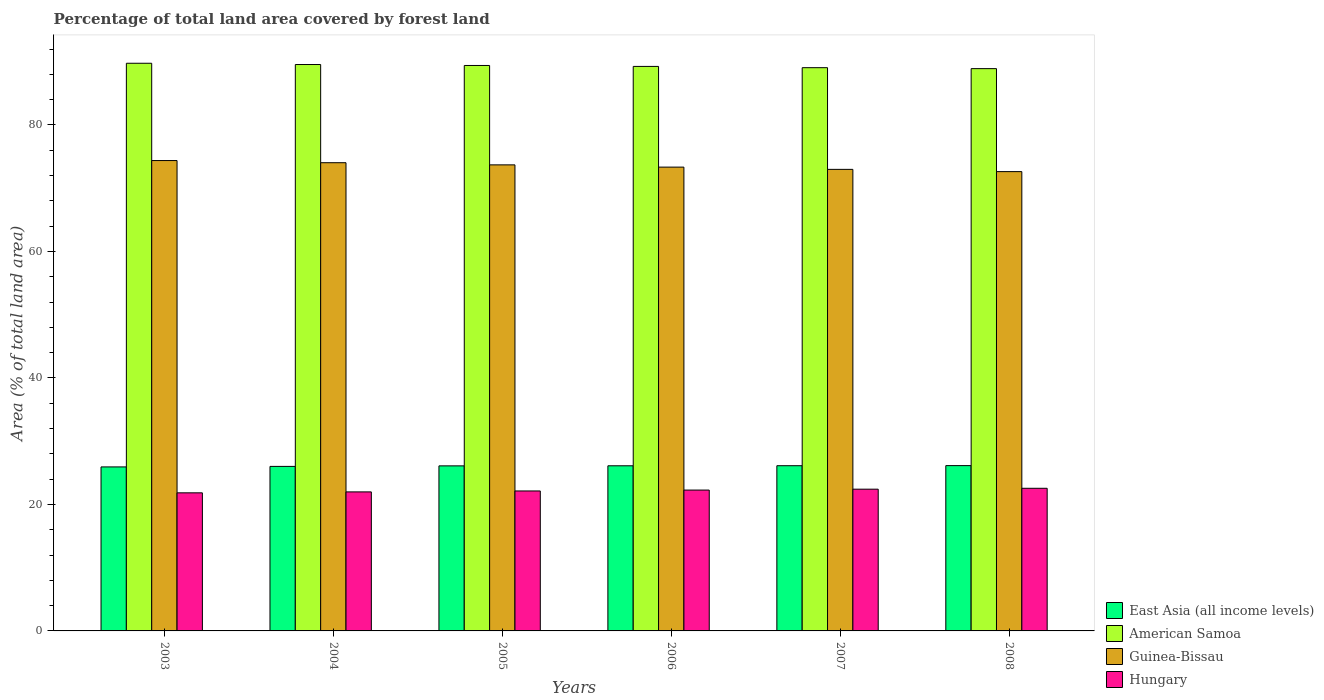Are the number of bars per tick equal to the number of legend labels?
Provide a succinct answer. Yes. How many bars are there on the 4th tick from the left?
Provide a succinct answer. 4. How many bars are there on the 3rd tick from the right?
Make the answer very short. 4. What is the label of the 2nd group of bars from the left?
Your response must be concise. 2004. What is the percentage of forest land in Guinea-Bissau in 2006?
Offer a very short reply. 73.33. Across all years, what is the maximum percentage of forest land in East Asia (all income levels)?
Keep it short and to the point. 26.14. Across all years, what is the minimum percentage of forest land in American Samoa?
Keep it short and to the point. 88.9. In which year was the percentage of forest land in East Asia (all income levels) minimum?
Give a very brief answer. 2003. What is the total percentage of forest land in Hungary in the graph?
Give a very brief answer. 133.17. What is the difference between the percentage of forest land in East Asia (all income levels) in 2005 and that in 2007?
Offer a very short reply. -0.03. What is the difference between the percentage of forest land in American Samoa in 2008 and the percentage of forest land in Hungary in 2003?
Give a very brief answer. 67.07. What is the average percentage of forest land in American Samoa per year?
Make the answer very short. 89.32. In the year 2007, what is the difference between the percentage of forest land in American Samoa and percentage of forest land in Guinea-Bissau?
Provide a short and direct response. 16.08. What is the ratio of the percentage of forest land in Guinea-Bissau in 2003 to that in 2008?
Offer a very short reply. 1.02. Is the percentage of forest land in American Samoa in 2004 less than that in 2008?
Offer a very short reply. No. What is the difference between the highest and the second highest percentage of forest land in Guinea-Bissau?
Your answer should be compact. 0.34. What is the difference between the highest and the lowest percentage of forest land in Guinea-Bissau?
Keep it short and to the point. 1.75. Is it the case that in every year, the sum of the percentage of forest land in Guinea-Bissau and percentage of forest land in Hungary is greater than the sum of percentage of forest land in East Asia (all income levels) and percentage of forest land in American Samoa?
Give a very brief answer. No. What does the 4th bar from the left in 2003 represents?
Offer a very short reply. Hungary. What does the 1st bar from the right in 2004 represents?
Provide a succinct answer. Hungary. Is it the case that in every year, the sum of the percentage of forest land in Hungary and percentage of forest land in East Asia (all income levels) is greater than the percentage of forest land in Guinea-Bissau?
Your answer should be very brief. No. How many bars are there?
Your response must be concise. 24. Are all the bars in the graph horizontal?
Your answer should be compact. No. What is the difference between two consecutive major ticks on the Y-axis?
Provide a short and direct response. 20. How many legend labels are there?
Keep it short and to the point. 4. What is the title of the graph?
Give a very brief answer. Percentage of total land area covered by forest land. Does "Nicaragua" appear as one of the legend labels in the graph?
Provide a short and direct response. No. What is the label or title of the Y-axis?
Give a very brief answer. Area (% of total land area). What is the Area (% of total land area) of East Asia (all income levels) in 2003?
Provide a short and direct response. 25.93. What is the Area (% of total land area) of American Samoa in 2003?
Your answer should be compact. 89.75. What is the Area (% of total land area) of Guinea-Bissau in 2003?
Provide a short and direct response. 74.37. What is the Area (% of total land area) in Hungary in 2003?
Make the answer very short. 21.83. What is the Area (% of total land area) of East Asia (all income levels) in 2004?
Your answer should be very brief. 26.01. What is the Area (% of total land area) of American Samoa in 2004?
Keep it short and to the point. 89.55. What is the Area (% of total land area) of Guinea-Bissau in 2004?
Give a very brief answer. 74.03. What is the Area (% of total land area) in Hungary in 2004?
Offer a very short reply. 21.98. What is the Area (% of total land area) of East Asia (all income levels) in 2005?
Make the answer very short. 26.09. What is the Area (% of total land area) of American Samoa in 2005?
Your answer should be very brief. 89.4. What is the Area (% of total land area) of Guinea-Bissau in 2005?
Keep it short and to the point. 73.68. What is the Area (% of total land area) in Hungary in 2005?
Keep it short and to the point. 22.13. What is the Area (% of total land area) of East Asia (all income levels) in 2006?
Keep it short and to the point. 26.11. What is the Area (% of total land area) in American Samoa in 2006?
Make the answer very short. 89.25. What is the Area (% of total land area) of Guinea-Bissau in 2006?
Your response must be concise. 73.33. What is the Area (% of total land area) in Hungary in 2006?
Offer a very short reply. 22.27. What is the Area (% of total land area) in East Asia (all income levels) in 2007?
Your response must be concise. 26.12. What is the Area (% of total land area) of American Samoa in 2007?
Offer a terse response. 89.05. What is the Area (% of total land area) in Guinea-Bissau in 2007?
Your response must be concise. 72.97. What is the Area (% of total land area) of Hungary in 2007?
Keep it short and to the point. 22.41. What is the Area (% of total land area) of East Asia (all income levels) in 2008?
Ensure brevity in your answer.  26.14. What is the Area (% of total land area) in American Samoa in 2008?
Offer a terse response. 88.9. What is the Area (% of total land area) of Guinea-Bissau in 2008?
Your response must be concise. 72.62. What is the Area (% of total land area) of Hungary in 2008?
Your answer should be very brief. 22.55. Across all years, what is the maximum Area (% of total land area) of East Asia (all income levels)?
Your answer should be very brief. 26.14. Across all years, what is the maximum Area (% of total land area) in American Samoa?
Provide a succinct answer. 89.75. Across all years, what is the maximum Area (% of total land area) in Guinea-Bissau?
Offer a terse response. 74.37. Across all years, what is the maximum Area (% of total land area) of Hungary?
Make the answer very short. 22.55. Across all years, what is the minimum Area (% of total land area) of East Asia (all income levels)?
Your answer should be very brief. 25.93. Across all years, what is the minimum Area (% of total land area) of American Samoa?
Give a very brief answer. 88.9. Across all years, what is the minimum Area (% of total land area) of Guinea-Bissau?
Provide a short and direct response. 72.62. Across all years, what is the minimum Area (% of total land area) of Hungary?
Provide a short and direct response. 21.83. What is the total Area (% of total land area) of East Asia (all income levels) in the graph?
Ensure brevity in your answer.  156.4. What is the total Area (% of total land area) in American Samoa in the graph?
Make the answer very short. 535.9. What is the total Area (% of total land area) of Guinea-Bissau in the graph?
Provide a short and direct response. 441. What is the total Area (% of total land area) in Hungary in the graph?
Give a very brief answer. 133.17. What is the difference between the Area (% of total land area) in East Asia (all income levels) in 2003 and that in 2004?
Offer a terse response. -0.08. What is the difference between the Area (% of total land area) in American Samoa in 2003 and that in 2004?
Your answer should be compact. 0.2. What is the difference between the Area (% of total land area) of Guinea-Bissau in 2003 and that in 2004?
Make the answer very short. 0.34. What is the difference between the Area (% of total land area) of Hungary in 2003 and that in 2004?
Offer a terse response. -0.15. What is the difference between the Area (% of total land area) in East Asia (all income levels) in 2003 and that in 2005?
Offer a very short reply. -0.16. What is the difference between the Area (% of total land area) of American Samoa in 2003 and that in 2005?
Your answer should be very brief. 0.35. What is the difference between the Area (% of total land area) of Guinea-Bissau in 2003 and that in 2005?
Ensure brevity in your answer.  0.68. What is the difference between the Area (% of total land area) of Hungary in 2003 and that in 2005?
Keep it short and to the point. -0.3. What is the difference between the Area (% of total land area) in East Asia (all income levels) in 2003 and that in 2006?
Ensure brevity in your answer.  -0.18. What is the difference between the Area (% of total land area) in American Samoa in 2003 and that in 2006?
Keep it short and to the point. 0.5. What is the difference between the Area (% of total land area) of Guinea-Bissau in 2003 and that in 2006?
Your response must be concise. 1.04. What is the difference between the Area (% of total land area) in Hungary in 2003 and that in 2006?
Keep it short and to the point. -0.44. What is the difference between the Area (% of total land area) of East Asia (all income levels) in 2003 and that in 2007?
Keep it short and to the point. -0.19. What is the difference between the Area (% of total land area) of American Samoa in 2003 and that in 2007?
Your response must be concise. 0.7. What is the difference between the Area (% of total land area) of Guinea-Bissau in 2003 and that in 2007?
Your answer should be compact. 1.39. What is the difference between the Area (% of total land area) of Hungary in 2003 and that in 2007?
Offer a very short reply. -0.58. What is the difference between the Area (% of total land area) of East Asia (all income levels) in 2003 and that in 2008?
Provide a short and direct response. -0.21. What is the difference between the Area (% of total land area) of Guinea-Bissau in 2003 and that in 2008?
Provide a short and direct response. 1.75. What is the difference between the Area (% of total land area) in Hungary in 2003 and that in 2008?
Provide a succinct answer. -0.72. What is the difference between the Area (% of total land area) in East Asia (all income levels) in 2004 and that in 2005?
Provide a succinct answer. -0.08. What is the difference between the Area (% of total land area) in Guinea-Bissau in 2004 and that in 2005?
Offer a terse response. 0.34. What is the difference between the Area (% of total land area) of Hungary in 2004 and that in 2005?
Provide a succinct answer. -0.15. What is the difference between the Area (% of total land area) in East Asia (all income levels) in 2004 and that in 2006?
Ensure brevity in your answer.  -0.1. What is the difference between the Area (% of total land area) of American Samoa in 2004 and that in 2006?
Your answer should be very brief. 0.3. What is the difference between the Area (% of total land area) in Guinea-Bissau in 2004 and that in 2006?
Provide a short and direct response. 0.7. What is the difference between the Area (% of total land area) in Hungary in 2004 and that in 2006?
Ensure brevity in your answer.  -0.29. What is the difference between the Area (% of total land area) of East Asia (all income levels) in 2004 and that in 2007?
Offer a very short reply. -0.11. What is the difference between the Area (% of total land area) of American Samoa in 2004 and that in 2007?
Your answer should be very brief. 0.5. What is the difference between the Area (% of total land area) in Guinea-Bissau in 2004 and that in 2007?
Keep it short and to the point. 1.05. What is the difference between the Area (% of total land area) in Hungary in 2004 and that in 2007?
Offer a terse response. -0.43. What is the difference between the Area (% of total land area) of East Asia (all income levels) in 2004 and that in 2008?
Your answer should be very brief. -0.12. What is the difference between the Area (% of total land area) in American Samoa in 2004 and that in 2008?
Make the answer very short. 0.65. What is the difference between the Area (% of total land area) of Guinea-Bissau in 2004 and that in 2008?
Provide a short and direct response. 1.41. What is the difference between the Area (% of total land area) of Hungary in 2004 and that in 2008?
Provide a succinct answer. -0.57. What is the difference between the Area (% of total land area) of East Asia (all income levels) in 2005 and that in 2006?
Provide a short and direct response. -0.01. What is the difference between the Area (% of total land area) in American Samoa in 2005 and that in 2006?
Your answer should be very brief. 0.15. What is the difference between the Area (% of total land area) of Guinea-Bissau in 2005 and that in 2006?
Your answer should be compact. 0.36. What is the difference between the Area (% of total land area) of Hungary in 2005 and that in 2006?
Provide a short and direct response. -0.14. What is the difference between the Area (% of total land area) of East Asia (all income levels) in 2005 and that in 2007?
Offer a very short reply. -0.03. What is the difference between the Area (% of total land area) of American Samoa in 2005 and that in 2007?
Offer a terse response. 0.35. What is the difference between the Area (% of total land area) in Guinea-Bissau in 2005 and that in 2007?
Your answer should be very brief. 0.71. What is the difference between the Area (% of total land area) in Hungary in 2005 and that in 2007?
Your answer should be compact. -0.28. What is the difference between the Area (% of total land area) in East Asia (all income levels) in 2005 and that in 2008?
Your response must be concise. -0.04. What is the difference between the Area (% of total land area) in Guinea-Bissau in 2005 and that in 2008?
Offer a terse response. 1.07. What is the difference between the Area (% of total land area) in Hungary in 2005 and that in 2008?
Make the answer very short. -0.42. What is the difference between the Area (% of total land area) of East Asia (all income levels) in 2006 and that in 2007?
Ensure brevity in your answer.  -0.01. What is the difference between the Area (% of total land area) in American Samoa in 2006 and that in 2007?
Keep it short and to the point. 0.2. What is the difference between the Area (% of total land area) in Guinea-Bissau in 2006 and that in 2007?
Offer a very short reply. 0.36. What is the difference between the Area (% of total land area) in Hungary in 2006 and that in 2007?
Provide a short and direct response. -0.14. What is the difference between the Area (% of total land area) of East Asia (all income levels) in 2006 and that in 2008?
Give a very brief answer. -0.03. What is the difference between the Area (% of total land area) of American Samoa in 2006 and that in 2008?
Your answer should be very brief. 0.35. What is the difference between the Area (% of total land area) of Guinea-Bissau in 2006 and that in 2008?
Ensure brevity in your answer.  0.71. What is the difference between the Area (% of total land area) of Hungary in 2006 and that in 2008?
Your answer should be compact. -0.28. What is the difference between the Area (% of total land area) of East Asia (all income levels) in 2007 and that in 2008?
Provide a succinct answer. -0.01. What is the difference between the Area (% of total land area) in Guinea-Bissau in 2007 and that in 2008?
Keep it short and to the point. 0.36. What is the difference between the Area (% of total land area) of Hungary in 2007 and that in 2008?
Provide a succinct answer. -0.14. What is the difference between the Area (% of total land area) of East Asia (all income levels) in 2003 and the Area (% of total land area) of American Samoa in 2004?
Provide a short and direct response. -63.62. What is the difference between the Area (% of total land area) of East Asia (all income levels) in 2003 and the Area (% of total land area) of Guinea-Bissau in 2004?
Your answer should be very brief. -48.1. What is the difference between the Area (% of total land area) of East Asia (all income levels) in 2003 and the Area (% of total land area) of Hungary in 2004?
Give a very brief answer. 3.95. What is the difference between the Area (% of total land area) in American Samoa in 2003 and the Area (% of total land area) in Guinea-Bissau in 2004?
Your answer should be very brief. 15.72. What is the difference between the Area (% of total land area) of American Samoa in 2003 and the Area (% of total land area) of Hungary in 2004?
Provide a short and direct response. 67.77. What is the difference between the Area (% of total land area) of Guinea-Bissau in 2003 and the Area (% of total land area) of Hungary in 2004?
Offer a very short reply. 52.39. What is the difference between the Area (% of total land area) in East Asia (all income levels) in 2003 and the Area (% of total land area) in American Samoa in 2005?
Give a very brief answer. -63.47. What is the difference between the Area (% of total land area) of East Asia (all income levels) in 2003 and the Area (% of total land area) of Guinea-Bissau in 2005?
Make the answer very short. -47.75. What is the difference between the Area (% of total land area) in East Asia (all income levels) in 2003 and the Area (% of total land area) in Hungary in 2005?
Offer a very short reply. 3.8. What is the difference between the Area (% of total land area) of American Samoa in 2003 and the Area (% of total land area) of Guinea-Bissau in 2005?
Keep it short and to the point. 16.07. What is the difference between the Area (% of total land area) in American Samoa in 2003 and the Area (% of total land area) in Hungary in 2005?
Ensure brevity in your answer.  67.62. What is the difference between the Area (% of total land area) of Guinea-Bissau in 2003 and the Area (% of total land area) of Hungary in 2005?
Provide a succinct answer. 52.24. What is the difference between the Area (% of total land area) in East Asia (all income levels) in 2003 and the Area (% of total land area) in American Samoa in 2006?
Provide a short and direct response. -63.32. What is the difference between the Area (% of total land area) of East Asia (all income levels) in 2003 and the Area (% of total land area) of Guinea-Bissau in 2006?
Offer a terse response. -47.4. What is the difference between the Area (% of total land area) in East Asia (all income levels) in 2003 and the Area (% of total land area) in Hungary in 2006?
Offer a terse response. 3.66. What is the difference between the Area (% of total land area) of American Samoa in 2003 and the Area (% of total land area) of Guinea-Bissau in 2006?
Your response must be concise. 16.42. What is the difference between the Area (% of total land area) of American Samoa in 2003 and the Area (% of total land area) of Hungary in 2006?
Your answer should be very brief. 67.48. What is the difference between the Area (% of total land area) in Guinea-Bissau in 2003 and the Area (% of total land area) in Hungary in 2006?
Keep it short and to the point. 52.1. What is the difference between the Area (% of total land area) of East Asia (all income levels) in 2003 and the Area (% of total land area) of American Samoa in 2007?
Give a very brief answer. -63.12. What is the difference between the Area (% of total land area) of East Asia (all income levels) in 2003 and the Area (% of total land area) of Guinea-Bissau in 2007?
Offer a terse response. -47.04. What is the difference between the Area (% of total land area) of East Asia (all income levels) in 2003 and the Area (% of total land area) of Hungary in 2007?
Keep it short and to the point. 3.52. What is the difference between the Area (% of total land area) of American Samoa in 2003 and the Area (% of total land area) of Guinea-Bissau in 2007?
Provide a succinct answer. 16.78. What is the difference between the Area (% of total land area) in American Samoa in 2003 and the Area (% of total land area) in Hungary in 2007?
Your response must be concise. 67.34. What is the difference between the Area (% of total land area) of Guinea-Bissau in 2003 and the Area (% of total land area) of Hungary in 2007?
Provide a short and direct response. 51.96. What is the difference between the Area (% of total land area) of East Asia (all income levels) in 2003 and the Area (% of total land area) of American Samoa in 2008?
Ensure brevity in your answer.  -62.97. What is the difference between the Area (% of total land area) of East Asia (all income levels) in 2003 and the Area (% of total land area) of Guinea-Bissau in 2008?
Offer a terse response. -46.69. What is the difference between the Area (% of total land area) in East Asia (all income levels) in 2003 and the Area (% of total land area) in Hungary in 2008?
Give a very brief answer. 3.38. What is the difference between the Area (% of total land area) in American Samoa in 2003 and the Area (% of total land area) in Guinea-Bissau in 2008?
Your response must be concise. 17.13. What is the difference between the Area (% of total land area) of American Samoa in 2003 and the Area (% of total land area) of Hungary in 2008?
Offer a very short reply. 67.2. What is the difference between the Area (% of total land area) of Guinea-Bissau in 2003 and the Area (% of total land area) of Hungary in 2008?
Your response must be concise. 51.82. What is the difference between the Area (% of total land area) in East Asia (all income levels) in 2004 and the Area (% of total land area) in American Samoa in 2005?
Your answer should be compact. -63.39. What is the difference between the Area (% of total land area) in East Asia (all income levels) in 2004 and the Area (% of total land area) in Guinea-Bissau in 2005?
Make the answer very short. -47.67. What is the difference between the Area (% of total land area) in East Asia (all income levels) in 2004 and the Area (% of total land area) in Hungary in 2005?
Your answer should be very brief. 3.88. What is the difference between the Area (% of total land area) of American Samoa in 2004 and the Area (% of total land area) of Guinea-Bissau in 2005?
Offer a very short reply. 15.87. What is the difference between the Area (% of total land area) in American Samoa in 2004 and the Area (% of total land area) in Hungary in 2005?
Give a very brief answer. 67.42. What is the difference between the Area (% of total land area) of Guinea-Bissau in 2004 and the Area (% of total land area) of Hungary in 2005?
Provide a short and direct response. 51.9. What is the difference between the Area (% of total land area) in East Asia (all income levels) in 2004 and the Area (% of total land area) in American Samoa in 2006?
Give a very brief answer. -63.24. What is the difference between the Area (% of total land area) in East Asia (all income levels) in 2004 and the Area (% of total land area) in Guinea-Bissau in 2006?
Your answer should be compact. -47.32. What is the difference between the Area (% of total land area) of East Asia (all income levels) in 2004 and the Area (% of total land area) of Hungary in 2006?
Ensure brevity in your answer.  3.74. What is the difference between the Area (% of total land area) of American Samoa in 2004 and the Area (% of total land area) of Guinea-Bissau in 2006?
Make the answer very short. 16.22. What is the difference between the Area (% of total land area) of American Samoa in 2004 and the Area (% of total land area) of Hungary in 2006?
Offer a terse response. 67.28. What is the difference between the Area (% of total land area) of Guinea-Bissau in 2004 and the Area (% of total land area) of Hungary in 2006?
Provide a succinct answer. 51.76. What is the difference between the Area (% of total land area) of East Asia (all income levels) in 2004 and the Area (% of total land area) of American Samoa in 2007?
Make the answer very short. -63.04. What is the difference between the Area (% of total land area) in East Asia (all income levels) in 2004 and the Area (% of total land area) in Guinea-Bissau in 2007?
Provide a short and direct response. -46.96. What is the difference between the Area (% of total land area) in East Asia (all income levels) in 2004 and the Area (% of total land area) in Hungary in 2007?
Make the answer very short. 3.6. What is the difference between the Area (% of total land area) of American Samoa in 2004 and the Area (% of total land area) of Guinea-Bissau in 2007?
Ensure brevity in your answer.  16.58. What is the difference between the Area (% of total land area) in American Samoa in 2004 and the Area (% of total land area) in Hungary in 2007?
Your response must be concise. 67.14. What is the difference between the Area (% of total land area) of Guinea-Bissau in 2004 and the Area (% of total land area) of Hungary in 2007?
Offer a very short reply. 51.62. What is the difference between the Area (% of total land area) in East Asia (all income levels) in 2004 and the Area (% of total land area) in American Samoa in 2008?
Give a very brief answer. -62.89. What is the difference between the Area (% of total land area) in East Asia (all income levels) in 2004 and the Area (% of total land area) in Guinea-Bissau in 2008?
Keep it short and to the point. -46.61. What is the difference between the Area (% of total land area) of East Asia (all income levels) in 2004 and the Area (% of total land area) of Hungary in 2008?
Your answer should be compact. 3.46. What is the difference between the Area (% of total land area) in American Samoa in 2004 and the Area (% of total land area) in Guinea-Bissau in 2008?
Offer a terse response. 16.93. What is the difference between the Area (% of total land area) of American Samoa in 2004 and the Area (% of total land area) of Hungary in 2008?
Your answer should be compact. 67. What is the difference between the Area (% of total land area) in Guinea-Bissau in 2004 and the Area (% of total land area) in Hungary in 2008?
Make the answer very short. 51.47. What is the difference between the Area (% of total land area) in East Asia (all income levels) in 2005 and the Area (% of total land area) in American Samoa in 2006?
Your answer should be compact. -63.16. What is the difference between the Area (% of total land area) of East Asia (all income levels) in 2005 and the Area (% of total land area) of Guinea-Bissau in 2006?
Provide a short and direct response. -47.23. What is the difference between the Area (% of total land area) of East Asia (all income levels) in 2005 and the Area (% of total land area) of Hungary in 2006?
Offer a very short reply. 3.82. What is the difference between the Area (% of total land area) in American Samoa in 2005 and the Area (% of total land area) in Guinea-Bissau in 2006?
Your answer should be very brief. 16.07. What is the difference between the Area (% of total land area) in American Samoa in 2005 and the Area (% of total land area) in Hungary in 2006?
Offer a terse response. 67.13. What is the difference between the Area (% of total land area) in Guinea-Bissau in 2005 and the Area (% of total land area) in Hungary in 2006?
Your answer should be compact. 51.41. What is the difference between the Area (% of total land area) of East Asia (all income levels) in 2005 and the Area (% of total land area) of American Samoa in 2007?
Make the answer very short. -62.96. What is the difference between the Area (% of total land area) of East Asia (all income levels) in 2005 and the Area (% of total land area) of Guinea-Bissau in 2007?
Offer a terse response. -46.88. What is the difference between the Area (% of total land area) of East Asia (all income levels) in 2005 and the Area (% of total land area) of Hungary in 2007?
Your response must be concise. 3.68. What is the difference between the Area (% of total land area) of American Samoa in 2005 and the Area (% of total land area) of Guinea-Bissau in 2007?
Offer a terse response. 16.43. What is the difference between the Area (% of total land area) of American Samoa in 2005 and the Area (% of total land area) of Hungary in 2007?
Provide a succinct answer. 66.99. What is the difference between the Area (% of total land area) in Guinea-Bissau in 2005 and the Area (% of total land area) in Hungary in 2007?
Offer a very short reply. 51.27. What is the difference between the Area (% of total land area) of East Asia (all income levels) in 2005 and the Area (% of total land area) of American Samoa in 2008?
Offer a very short reply. -62.81. What is the difference between the Area (% of total land area) of East Asia (all income levels) in 2005 and the Area (% of total land area) of Guinea-Bissau in 2008?
Provide a short and direct response. -46.52. What is the difference between the Area (% of total land area) in East Asia (all income levels) in 2005 and the Area (% of total land area) in Hungary in 2008?
Your response must be concise. 3.54. What is the difference between the Area (% of total land area) in American Samoa in 2005 and the Area (% of total land area) in Guinea-Bissau in 2008?
Offer a very short reply. 16.78. What is the difference between the Area (% of total land area) in American Samoa in 2005 and the Area (% of total land area) in Hungary in 2008?
Your answer should be compact. 66.85. What is the difference between the Area (% of total land area) in Guinea-Bissau in 2005 and the Area (% of total land area) in Hungary in 2008?
Offer a very short reply. 51.13. What is the difference between the Area (% of total land area) of East Asia (all income levels) in 2006 and the Area (% of total land area) of American Samoa in 2007?
Your answer should be compact. -62.94. What is the difference between the Area (% of total land area) in East Asia (all income levels) in 2006 and the Area (% of total land area) in Guinea-Bissau in 2007?
Give a very brief answer. -46.87. What is the difference between the Area (% of total land area) of East Asia (all income levels) in 2006 and the Area (% of total land area) of Hungary in 2007?
Your answer should be compact. 3.7. What is the difference between the Area (% of total land area) of American Samoa in 2006 and the Area (% of total land area) of Guinea-Bissau in 2007?
Ensure brevity in your answer.  16.28. What is the difference between the Area (% of total land area) of American Samoa in 2006 and the Area (% of total land area) of Hungary in 2007?
Ensure brevity in your answer.  66.84. What is the difference between the Area (% of total land area) of Guinea-Bissau in 2006 and the Area (% of total land area) of Hungary in 2007?
Ensure brevity in your answer.  50.92. What is the difference between the Area (% of total land area) of East Asia (all income levels) in 2006 and the Area (% of total land area) of American Samoa in 2008?
Make the answer very short. -62.79. What is the difference between the Area (% of total land area) of East Asia (all income levels) in 2006 and the Area (% of total land area) of Guinea-Bissau in 2008?
Your answer should be very brief. -46.51. What is the difference between the Area (% of total land area) of East Asia (all income levels) in 2006 and the Area (% of total land area) of Hungary in 2008?
Offer a very short reply. 3.56. What is the difference between the Area (% of total land area) of American Samoa in 2006 and the Area (% of total land area) of Guinea-Bissau in 2008?
Give a very brief answer. 16.63. What is the difference between the Area (% of total land area) in American Samoa in 2006 and the Area (% of total land area) in Hungary in 2008?
Your response must be concise. 66.7. What is the difference between the Area (% of total land area) in Guinea-Bissau in 2006 and the Area (% of total land area) in Hungary in 2008?
Give a very brief answer. 50.78. What is the difference between the Area (% of total land area) of East Asia (all income levels) in 2007 and the Area (% of total land area) of American Samoa in 2008?
Your answer should be very brief. -62.78. What is the difference between the Area (% of total land area) of East Asia (all income levels) in 2007 and the Area (% of total land area) of Guinea-Bissau in 2008?
Provide a succinct answer. -46.5. What is the difference between the Area (% of total land area) of East Asia (all income levels) in 2007 and the Area (% of total land area) of Hungary in 2008?
Provide a succinct answer. 3.57. What is the difference between the Area (% of total land area) in American Samoa in 2007 and the Area (% of total land area) in Guinea-Bissau in 2008?
Provide a succinct answer. 16.43. What is the difference between the Area (% of total land area) in American Samoa in 2007 and the Area (% of total land area) in Hungary in 2008?
Give a very brief answer. 66.5. What is the difference between the Area (% of total land area) in Guinea-Bissau in 2007 and the Area (% of total land area) in Hungary in 2008?
Your response must be concise. 50.42. What is the average Area (% of total land area) of East Asia (all income levels) per year?
Offer a terse response. 26.07. What is the average Area (% of total land area) of American Samoa per year?
Offer a terse response. 89.32. What is the average Area (% of total land area) of Guinea-Bissau per year?
Keep it short and to the point. 73.5. What is the average Area (% of total land area) in Hungary per year?
Ensure brevity in your answer.  22.2. In the year 2003, what is the difference between the Area (% of total land area) of East Asia (all income levels) and Area (% of total land area) of American Samoa?
Provide a succinct answer. -63.82. In the year 2003, what is the difference between the Area (% of total land area) of East Asia (all income levels) and Area (% of total land area) of Guinea-Bissau?
Your answer should be very brief. -48.44. In the year 2003, what is the difference between the Area (% of total land area) of East Asia (all income levels) and Area (% of total land area) of Hungary?
Give a very brief answer. 4.1. In the year 2003, what is the difference between the Area (% of total land area) of American Samoa and Area (% of total land area) of Guinea-Bissau?
Make the answer very short. 15.38. In the year 2003, what is the difference between the Area (% of total land area) of American Samoa and Area (% of total land area) of Hungary?
Your answer should be compact. 67.92. In the year 2003, what is the difference between the Area (% of total land area) in Guinea-Bissau and Area (% of total land area) in Hungary?
Your answer should be compact. 52.53. In the year 2004, what is the difference between the Area (% of total land area) of East Asia (all income levels) and Area (% of total land area) of American Samoa?
Ensure brevity in your answer.  -63.54. In the year 2004, what is the difference between the Area (% of total land area) in East Asia (all income levels) and Area (% of total land area) in Guinea-Bissau?
Give a very brief answer. -48.01. In the year 2004, what is the difference between the Area (% of total land area) in East Asia (all income levels) and Area (% of total land area) in Hungary?
Give a very brief answer. 4.03. In the year 2004, what is the difference between the Area (% of total land area) in American Samoa and Area (% of total land area) in Guinea-Bissau?
Provide a short and direct response. 15.52. In the year 2004, what is the difference between the Area (% of total land area) of American Samoa and Area (% of total land area) of Hungary?
Offer a terse response. 67.57. In the year 2004, what is the difference between the Area (% of total land area) in Guinea-Bissau and Area (% of total land area) in Hungary?
Your answer should be very brief. 52.05. In the year 2005, what is the difference between the Area (% of total land area) of East Asia (all income levels) and Area (% of total land area) of American Samoa?
Provide a short and direct response. -63.31. In the year 2005, what is the difference between the Area (% of total land area) in East Asia (all income levels) and Area (% of total land area) in Guinea-Bissau?
Your response must be concise. -47.59. In the year 2005, what is the difference between the Area (% of total land area) of East Asia (all income levels) and Area (% of total land area) of Hungary?
Give a very brief answer. 3.97. In the year 2005, what is the difference between the Area (% of total land area) in American Samoa and Area (% of total land area) in Guinea-Bissau?
Give a very brief answer. 15.72. In the year 2005, what is the difference between the Area (% of total land area) in American Samoa and Area (% of total land area) in Hungary?
Make the answer very short. 67.27. In the year 2005, what is the difference between the Area (% of total land area) in Guinea-Bissau and Area (% of total land area) in Hungary?
Keep it short and to the point. 51.55. In the year 2006, what is the difference between the Area (% of total land area) in East Asia (all income levels) and Area (% of total land area) in American Samoa?
Keep it short and to the point. -63.14. In the year 2006, what is the difference between the Area (% of total land area) in East Asia (all income levels) and Area (% of total land area) in Guinea-Bissau?
Give a very brief answer. -47.22. In the year 2006, what is the difference between the Area (% of total land area) in East Asia (all income levels) and Area (% of total land area) in Hungary?
Offer a very short reply. 3.84. In the year 2006, what is the difference between the Area (% of total land area) in American Samoa and Area (% of total land area) in Guinea-Bissau?
Keep it short and to the point. 15.92. In the year 2006, what is the difference between the Area (% of total land area) of American Samoa and Area (% of total land area) of Hungary?
Your response must be concise. 66.98. In the year 2006, what is the difference between the Area (% of total land area) of Guinea-Bissau and Area (% of total land area) of Hungary?
Your response must be concise. 51.06. In the year 2007, what is the difference between the Area (% of total land area) in East Asia (all income levels) and Area (% of total land area) in American Samoa?
Offer a very short reply. -62.93. In the year 2007, what is the difference between the Area (% of total land area) of East Asia (all income levels) and Area (% of total land area) of Guinea-Bissau?
Your answer should be compact. -46.85. In the year 2007, what is the difference between the Area (% of total land area) of East Asia (all income levels) and Area (% of total land area) of Hungary?
Make the answer very short. 3.71. In the year 2007, what is the difference between the Area (% of total land area) in American Samoa and Area (% of total land area) in Guinea-Bissau?
Your answer should be very brief. 16.08. In the year 2007, what is the difference between the Area (% of total land area) in American Samoa and Area (% of total land area) in Hungary?
Make the answer very short. 66.64. In the year 2007, what is the difference between the Area (% of total land area) of Guinea-Bissau and Area (% of total land area) of Hungary?
Keep it short and to the point. 50.56. In the year 2008, what is the difference between the Area (% of total land area) of East Asia (all income levels) and Area (% of total land area) of American Samoa?
Your response must be concise. -62.76. In the year 2008, what is the difference between the Area (% of total land area) of East Asia (all income levels) and Area (% of total land area) of Guinea-Bissau?
Offer a very short reply. -46.48. In the year 2008, what is the difference between the Area (% of total land area) in East Asia (all income levels) and Area (% of total land area) in Hungary?
Offer a very short reply. 3.58. In the year 2008, what is the difference between the Area (% of total land area) of American Samoa and Area (% of total land area) of Guinea-Bissau?
Make the answer very short. 16.28. In the year 2008, what is the difference between the Area (% of total land area) in American Samoa and Area (% of total land area) in Hungary?
Offer a terse response. 66.35. In the year 2008, what is the difference between the Area (% of total land area) in Guinea-Bissau and Area (% of total land area) in Hungary?
Provide a short and direct response. 50.07. What is the ratio of the Area (% of total land area) of East Asia (all income levels) in 2003 to that in 2004?
Keep it short and to the point. 1. What is the ratio of the Area (% of total land area) of Guinea-Bissau in 2003 to that in 2004?
Offer a very short reply. 1. What is the ratio of the Area (% of total land area) of Guinea-Bissau in 2003 to that in 2005?
Provide a short and direct response. 1.01. What is the ratio of the Area (% of total land area) in Hungary in 2003 to that in 2005?
Offer a terse response. 0.99. What is the ratio of the Area (% of total land area) in East Asia (all income levels) in 2003 to that in 2006?
Provide a succinct answer. 0.99. What is the ratio of the Area (% of total land area) in American Samoa in 2003 to that in 2006?
Keep it short and to the point. 1.01. What is the ratio of the Area (% of total land area) in Guinea-Bissau in 2003 to that in 2006?
Provide a succinct answer. 1.01. What is the ratio of the Area (% of total land area) of Hungary in 2003 to that in 2006?
Offer a terse response. 0.98. What is the ratio of the Area (% of total land area) of East Asia (all income levels) in 2003 to that in 2007?
Provide a short and direct response. 0.99. What is the ratio of the Area (% of total land area) in American Samoa in 2003 to that in 2007?
Make the answer very short. 1.01. What is the ratio of the Area (% of total land area) of Guinea-Bissau in 2003 to that in 2007?
Offer a very short reply. 1.02. What is the ratio of the Area (% of total land area) in Hungary in 2003 to that in 2007?
Provide a short and direct response. 0.97. What is the ratio of the Area (% of total land area) in East Asia (all income levels) in 2003 to that in 2008?
Make the answer very short. 0.99. What is the ratio of the Area (% of total land area) in American Samoa in 2003 to that in 2008?
Provide a short and direct response. 1.01. What is the ratio of the Area (% of total land area) of Guinea-Bissau in 2003 to that in 2008?
Your answer should be compact. 1.02. What is the ratio of the Area (% of total land area) in Hungary in 2003 to that in 2008?
Provide a succinct answer. 0.97. What is the ratio of the Area (% of total land area) of American Samoa in 2004 to that in 2005?
Provide a succinct answer. 1. What is the ratio of the Area (% of total land area) of Guinea-Bissau in 2004 to that in 2005?
Offer a terse response. 1. What is the ratio of the Area (% of total land area) in Hungary in 2004 to that in 2005?
Provide a short and direct response. 0.99. What is the ratio of the Area (% of total land area) in American Samoa in 2004 to that in 2006?
Provide a short and direct response. 1. What is the ratio of the Area (% of total land area) in Guinea-Bissau in 2004 to that in 2006?
Offer a terse response. 1.01. What is the ratio of the Area (% of total land area) in Hungary in 2004 to that in 2006?
Your response must be concise. 0.99. What is the ratio of the Area (% of total land area) in East Asia (all income levels) in 2004 to that in 2007?
Your answer should be very brief. 1. What is the ratio of the Area (% of total land area) in American Samoa in 2004 to that in 2007?
Keep it short and to the point. 1.01. What is the ratio of the Area (% of total land area) in Guinea-Bissau in 2004 to that in 2007?
Your answer should be very brief. 1.01. What is the ratio of the Area (% of total land area) of Hungary in 2004 to that in 2007?
Your answer should be very brief. 0.98. What is the ratio of the Area (% of total land area) in American Samoa in 2004 to that in 2008?
Make the answer very short. 1.01. What is the ratio of the Area (% of total land area) of Guinea-Bissau in 2004 to that in 2008?
Keep it short and to the point. 1.02. What is the ratio of the Area (% of total land area) in Hungary in 2004 to that in 2008?
Provide a succinct answer. 0.97. What is the ratio of the Area (% of total land area) in East Asia (all income levels) in 2005 to that in 2006?
Provide a succinct answer. 1. What is the ratio of the Area (% of total land area) in American Samoa in 2005 to that in 2006?
Provide a succinct answer. 1. What is the ratio of the Area (% of total land area) in Hungary in 2005 to that in 2006?
Make the answer very short. 0.99. What is the ratio of the Area (% of total land area) of American Samoa in 2005 to that in 2007?
Ensure brevity in your answer.  1. What is the ratio of the Area (% of total land area) of Guinea-Bissau in 2005 to that in 2007?
Offer a terse response. 1.01. What is the ratio of the Area (% of total land area) in Hungary in 2005 to that in 2007?
Your answer should be compact. 0.99. What is the ratio of the Area (% of total land area) of American Samoa in 2005 to that in 2008?
Keep it short and to the point. 1.01. What is the ratio of the Area (% of total land area) in Guinea-Bissau in 2005 to that in 2008?
Keep it short and to the point. 1.01. What is the ratio of the Area (% of total land area) of Hungary in 2005 to that in 2008?
Your response must be concise. 0.98. What is the ratio of the Area (% of total land area) in East Asia (all income levels) in 2006 to that in 2007?
Provide a short and direct response. 1. What is the ratio of the Area (% of total land area) of Guinea-Bissau in 2006 to that in 2007?
Your response must be concise. 1. What is the ratio of the Area (% of total land area) of East Asia (all income levels) in 2006 to that in 2008?
Give a very brief answer. 1. What is the ratio of the Area (% of total land area) of Guinea-Bissau in 2006 to that in 2008?
Offer a very short reply. 1.01. What is the ratio of the Area (% of total land area) in Hungary in 2006 to that in 2008?
Offer a very short reply. 0.99. What is the ratio of the Area (% of total land area) of East Asia (all income levels) in 2007 to that in 2008?
Your answer should be very brief. 1. What is the ratio of the Area (% of total land area) in American Samoa in 2007 to that in 2008?
Your response must be concise. 1. What is the difference between the highest and the second highest Area (% of total land area) of East Asia (all income levels)?
Your response must be concise. 0.01. What is the difference between the highest and the second highest Area (% of total land area) of Guinea-Bissau?
Keep it short and to the point. 0.34. What is the difference between the highest and the second highest Area (% of total land area) of Hungary?
Ensure brevity in your answer.  0.14. What is the difference between the highest and the lowest Area (% of total land area) in East Asia (all income levels)?
Your response must be concise. 0.21. What is the difference between the highest and the lowest Area (% of total land area) in Guinea-Bissau?
Provide a succinct answer. 1.75. What is the difference between the highest and the lowest Area (% of total land area) of Hungary?
Your response must be concise. 0.72. 